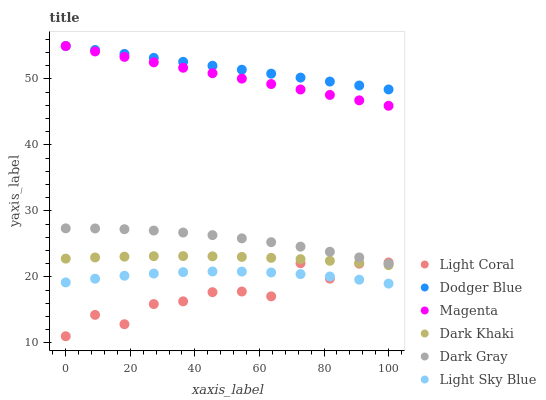Does Light Coral have the minimum area under the curve?
Answer yes or no. Yes. Does Dodger Blue have the maximum area under the curve?
Answer yes or no. Yes. Does Dark Gray have the minimum area under the curve?
Answer yes or no. No. Does Dark Gray have the maximum area under the curve?
Answer yes or no. No. Is Magenta the smoothest?
Answer yes or no. Yes. Is Light Coral the roughest?
Answer yes or no. Yes. Is Dark Gray the smoothest?
Answer yes or no. No. Is Dark Gray the roughest?
Answer yes or no. No. Does Light Coral have the lowest value?
Answer yes or no. Yes. Does Dark Gray have the lowest value?
Answer yes or no. No. Does Magenta have the highest value?
Answer yes or no. Yes. Does Dark Gray have the highest value?
Answer yes or no. No. Is Light Sky Blue less than Dodger Blue?
Answer yes or no. Yes. Is Dark Gray greater than Dark Khaki?
Answer yes or no. Yes. Does Magenta intersect Dodger Blue?
Answer yes or no. Yes. Is Magenta less than Dodger Blue?
Answer yes or no. No. Is Magenta greater than Dodger Blue?
Answer yes or no. No. Does Light Sky Blue intersect Dodger Blue?
Answer yes or no. No. 